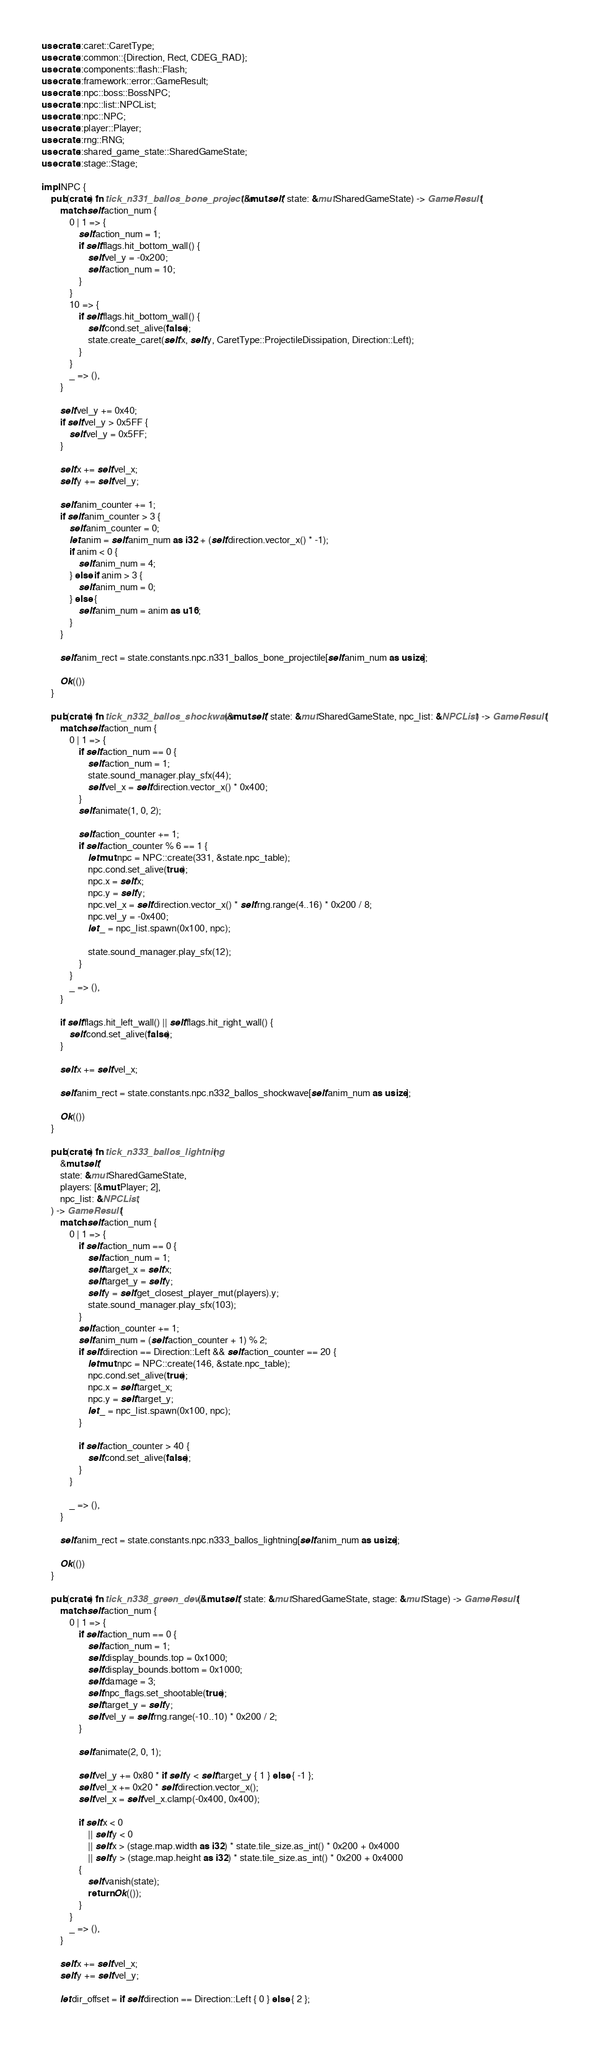Convert code to text. <code><loc_0><loc_0><loc_500><loc_500><_Rust_>use crate::caret::CaretType;
use crate::common::{Direction, Rect, CDEG_RAD};
use crate::components::flash::Flash;
use crate::framework::error::GameResult;
use crate::npc::boss::BossNPC;
use crate::npc::list::NPCList;
use crate::npc::NPC;
use crate::player::Player;
use crate::rng::RNG;
use crate::shared_game_state::SharedGameState;
use crate::stage::Stage;

impl NPC {
    pub(crate) fn tick_n331_ballos_bone_projectile(&mut self, state: &mut SharedGameState) -> GameResult {
        match self.action_num {
            0 | 1 => {
                self.action_num = 1;
                if self.flags.hit_bottom_wall() {
                    self.vel_y = -0x200;
                    self.action_num = 10;
                }
            }
            10 => {
                if self.flags.hit_bottom_wall() {
                    self.cond.set_alive(false);
                    state.create_caret(self.x, self.y, CaretType::ProjectileDissipation, Direction::Left);
                }
            }
            _ => (),
        }

        self.vel_y += 0x40;
        if self.vel_y > 0x5FF {
            self.vel_y = 0x5FF;
        }

        self.x += self.vel_x;
        self.y += self.vel_y;

        self.anim_counter += 1;
        if self.anim_counter > 3 {
            self.anim_counter = 0;
            let anim = self.anim_num as i32 + (self.direction.vector_x() * -1);
            if anim < 0 {
                self.anim_num = 4;
            } else if anim > 3 {
                self.anim_num = 0;
            } else {
                self.anim_num = anim as u16;
            }
        }

        self.anim_rect = state.constants.npc.n331_ballos_bone_projectile[self.anim_num as usize];

        Ok(())
    }

    pub(crate) fn tick_n332_ballos_shockwave(&mut self, state: &mut SharedGameState, npc_list: &NPCList) -> GameResult {
        match self.action_num {
            0 | 1 => {
                if self.action_num == 0 {
                    self.action_num = 1;
                    state.sound_manager.play_sfx(44);
                    self.vel_x = self.direction.vector_x() * 0x400;
                }
                self.animate(1, 0, 2);

                self.action_counter += 1;
                if self.action_counter % 6 == 1 {
                    let mut npc = NPC::create(331, &state.npc_table);
                    npc.cond.set_alive(true);
                    npc.x = self.x;
                    npc.y = self.y;
                    npc.vel_x = self.direction.vector_x() * self.rng.range(4..16) * 0x200 / 8;
                    npc.vel_y = -0x400;
                    let _ = npc_list.spawn(0x100, npc);

                    state.sound_manager.play_sfx(12);
                }
            }
            _ => (),
        }

        if self.flags.hit_left_wall() || self.flags.hit_right_wall() {
            self.cond.set_alive(false);
        }

        self.x += self.vel_x;

        self.anim_rect = state.constants.npc.n332_ballos_shockwave[self.anim_num as usize];

        Ok(())
    }

    pub(crate) fn tick_n333_ballos_lightning(
        &mut self,
        state: &mut SharedGameState,
        players: [&mut Player; 2],
        npc_list: &NPCList,
    ) -> GameResult {
        match self.action_num {
            0 | 1 => {
                if self.action_num == 0 {
                    self.action_num = 1;
                    self.target_x = self.x;
                    self.target_y = self.y;
                    self.y = self.get_closest_player_mut(players).y;
                    state.sound_manager.play_sfx(103);
                }
                self.action_counter += 1;
                self.anim_num = (self.action_counter + 1) % 2;
                if self.direction == Direction::Left && self.action_counter == 20 {
                    let mut npc = NPC::create(146, &state.npc_table);
                    npc.cond.set_alive(true);
                    npc.x = self.target_x;
                    npc.y = self.target_y;
                    let _ = npc_list.spawn(0x100, npc);
                }

                if self.action_counter > 40 {
                    self.cond.set_alive(false);
                }
            }

            _ => (),
        }

        self.anim_rect = state.constants.npc.n333_ballos_lightning[self.anim_num as usize];

        Ok(())
    }

    pub(crate) fn tick_n338_green_devil(&mut self, state: &mut SharedGameState, stage: &mut Stage) -> GameResult {
        match self.action_num {
            0 | 1 => {
                if self.action_num == 0 {
                    self.action_num = 1;
                    self.display_bounds.top = 0x1000;
                    self.display_bounds.bottom = 0x1000;
                    self.damage = 3;
                    self.npc_flags.set_shootable(true);
                    self.target_y = self.y;
                    self.vel_y = self.rng.range(-10..10) * 0x200 / 2;
                }

                self.animate(2, 0, 1);

                self.vel_y += 0x80 * if self.y < self.target_y { 1 } else { -1 };
                self.vel_x += 0x20 * self.direction.vector_x();
                self.vel_x = self.vel_x.clamp(-0x400, 0x400);

                if self.x < 0
                    || self.y < 0
                    || self.x > (stage.map.width as i32) * state.tile_size.as_int() * 0x200 + 0x4000
                    || self.y > (stage.map.height as i32) * state.tile_size.as_int() * 0x200 + 0x4000
                {
                    self.vanish(state);
                    return Ok(());
                }
            }
            _ => (),
        }

        self.x += self.vel_x;
        self.y += self.vel_y;

        let dir_offset = if self.direction == Direction::Left { 0 } else { 2 };</code> 